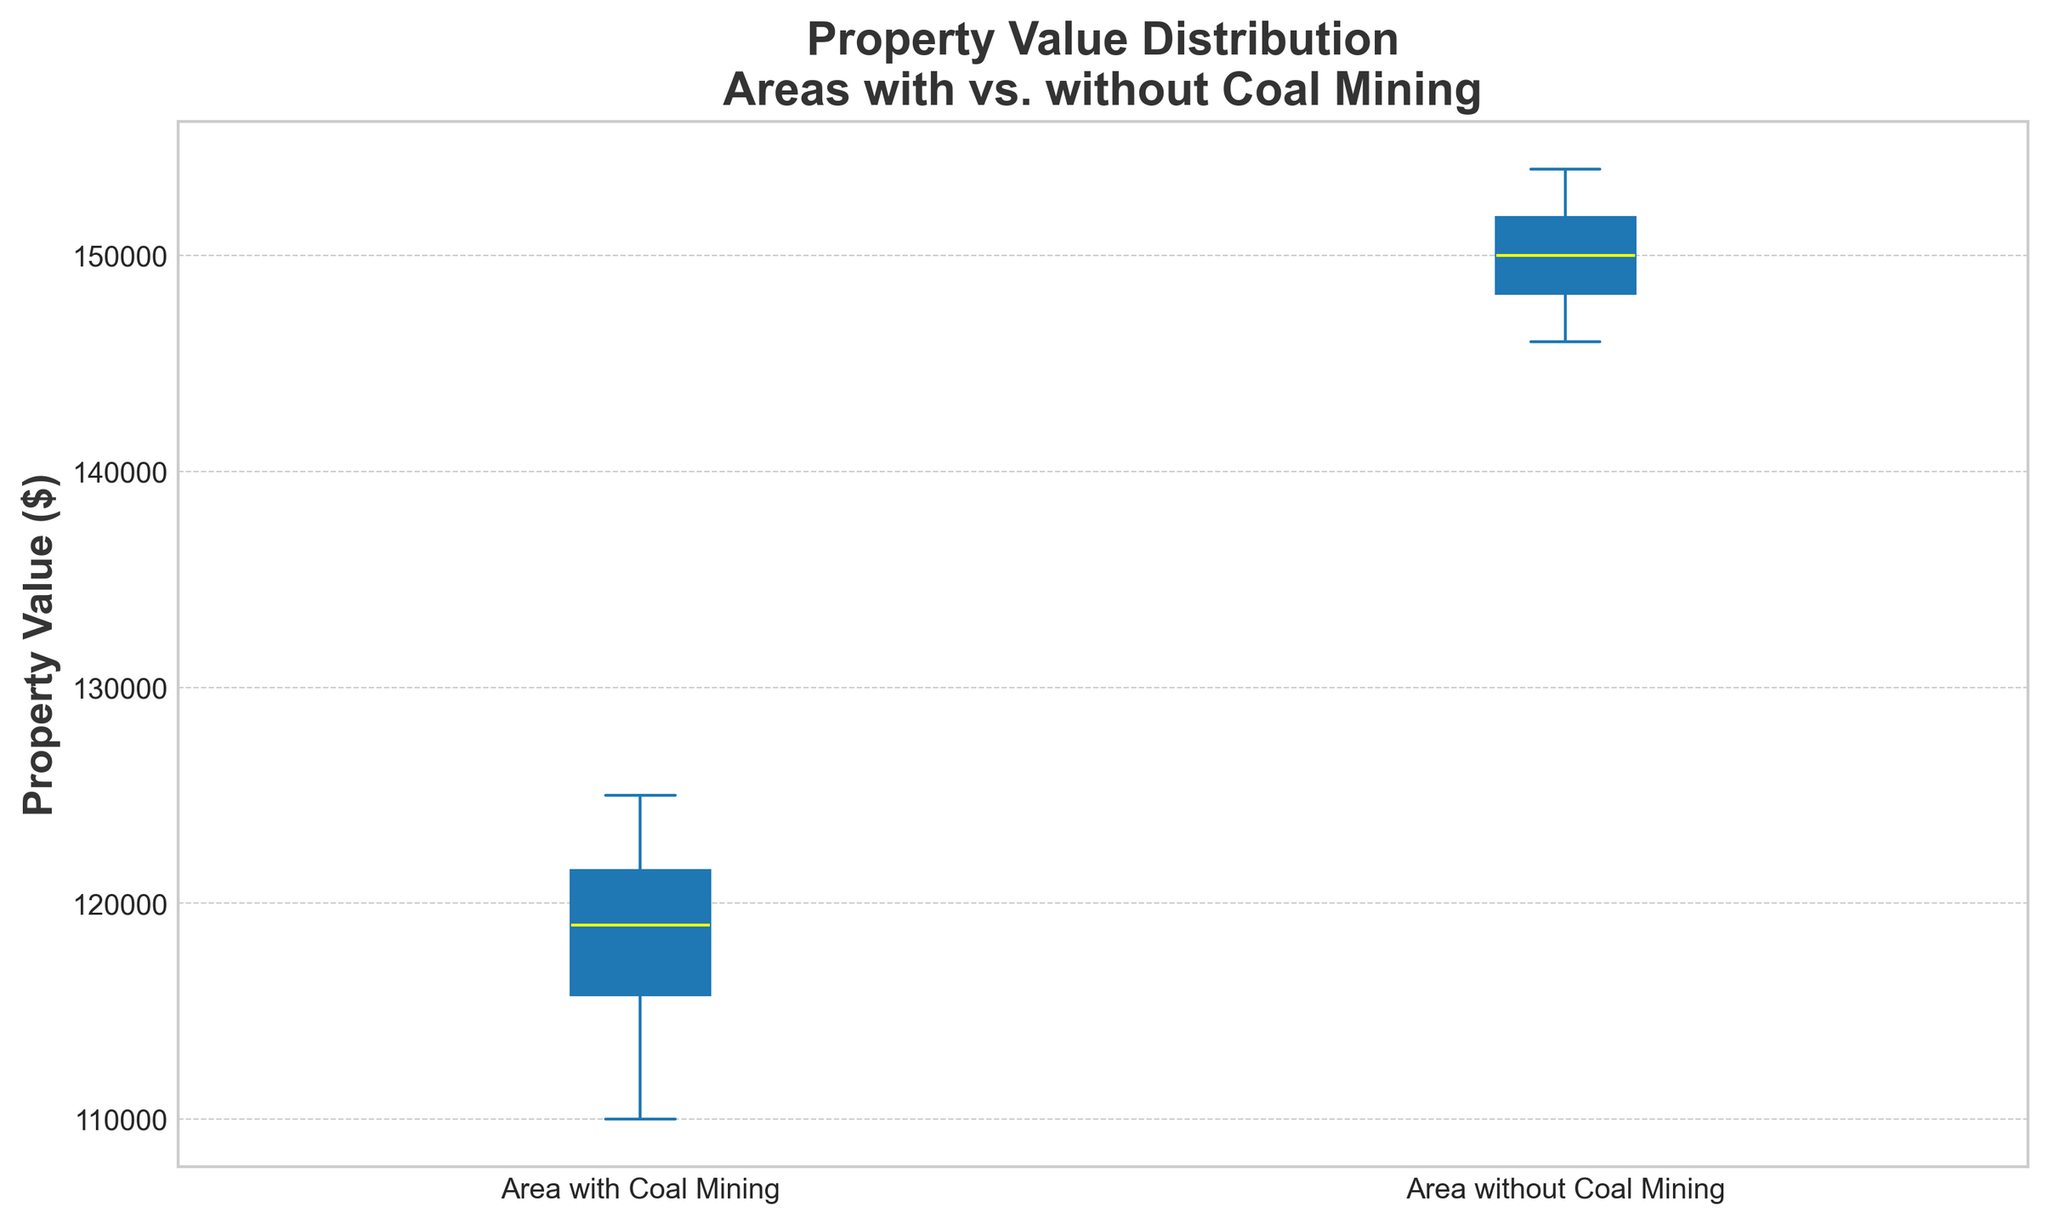What are the median property values of both areas? The median is indicated by the yellow line in each box plot. For the areas with coal mining, the median property value is approximated from its position, whereas for areas without coal mining, it is approximated from its respective position.
Answer: $118,000 and $150,000 Which area has the higher median property value? The yellow line inside the box represents the median. By comparing the lines in both boxes, it is clear that the median of the area without coal mining is higher.
Answer: Area without Coal Mining What is the range (difference between maximum and minimum values) of property values in each area? The range is determined by the whiskers extending from the lowest to highest values in each box plot. We can refer to the data points to calculate exact ranges, which are approximately $125,000 - $110,000 for coal mining areas and $154,000 - $146,000 for areas without coal mining.
Answer: $15,000 for coal mining, $8,000 for no coal mining Which area has a wider interquartile range (IQR) of property values? The IQR is represented by the height of the box. By comparing both boxes, the area with coal mining has a taller box, indicating a wider IQR.
Answer: Area with Coal Mining Are there any outliers in the property values? Outliers are typically represented by small dots outside the 'whiskers' of the box plots. In this visualization, there are no such dots, indicating no outliers.
Answer: No Which area has a more tightly clustered distribution of property values? Tighter clustering is indicated by a smaller range and smaller IQR. The area without coal mining has both a smaller range and a smaller IQR, indicating a more tightly clustered distribution.
Answer: Area without Coal Mining How does the median property value in areas with coal mining compare to the first quartile in areas without coal mining? The first quartile is the bottom of the box. The median value in areas with coal mining is approximately $118,000, which is lower than the first quartile in areas without coal mining, approximated at $147,000.
Answer: Lower What can be inferred about the property values in areas with coal mining based on their distribution? The box plot for areas with coal mining shows a wide range with a lower median, indicating that property values are generally lower and more variable compared to areas without coal mining.
Answer: Lower and more variable 